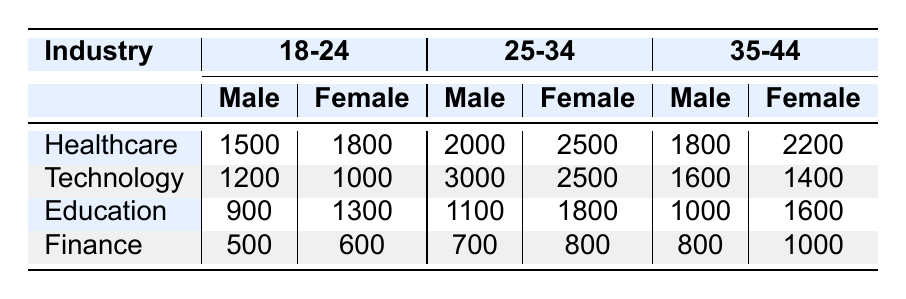What is the total number of female volunteers in the Healthcare industry for the age group 25-34? Referring to the table, for the Healthcare industry and the age group 25-34, the number of female volunteers is 2500.
Answer: 2500 What industry has the highest number of volunteers aged 18-24? Looking at the age group 18-24, the total volunteers for each industry are: Healthcare (3300), Technology (2200), Education (2200), and Finance (1100). Healthcare has the highest total of 3300 volunteers in this age group.
Answer: Healthcare How many more male volunteers are there in the Technology industry compared to the Finance industry for the age group 35-44? For the Technology industry aged 35-44, the number of male volunteers is 1600. For the Finance industry in the same age group, the number of male volunteers is 800. The difference is 1600 - 800 = 800.
Answer: 800 Is the total number of volunteers in the Education industry for age group 25-34 greater than the total in the Finance industry for the same age group? The total volunteers in the Education industry for age group 25-34 is 2900, while the total in Finance for the same age group is 1500. Since 2900 is greater than 1500, the statement is true.
Answer: Yes What is the average number of male and female volunteers in the Healthcare industry across all age groups? The total number of male volunteers in Healthcare across all age groups is 1500 + 2000 + 1800 = 5300. The total number of female volunteers is 1800 + 2500 + 2200 = 6500. The average for males is 5300 / 3 = 1766.67, and for females, it is 6500 / 3 = 2166.67.
Answer: Males: 1767, Females: 2167 